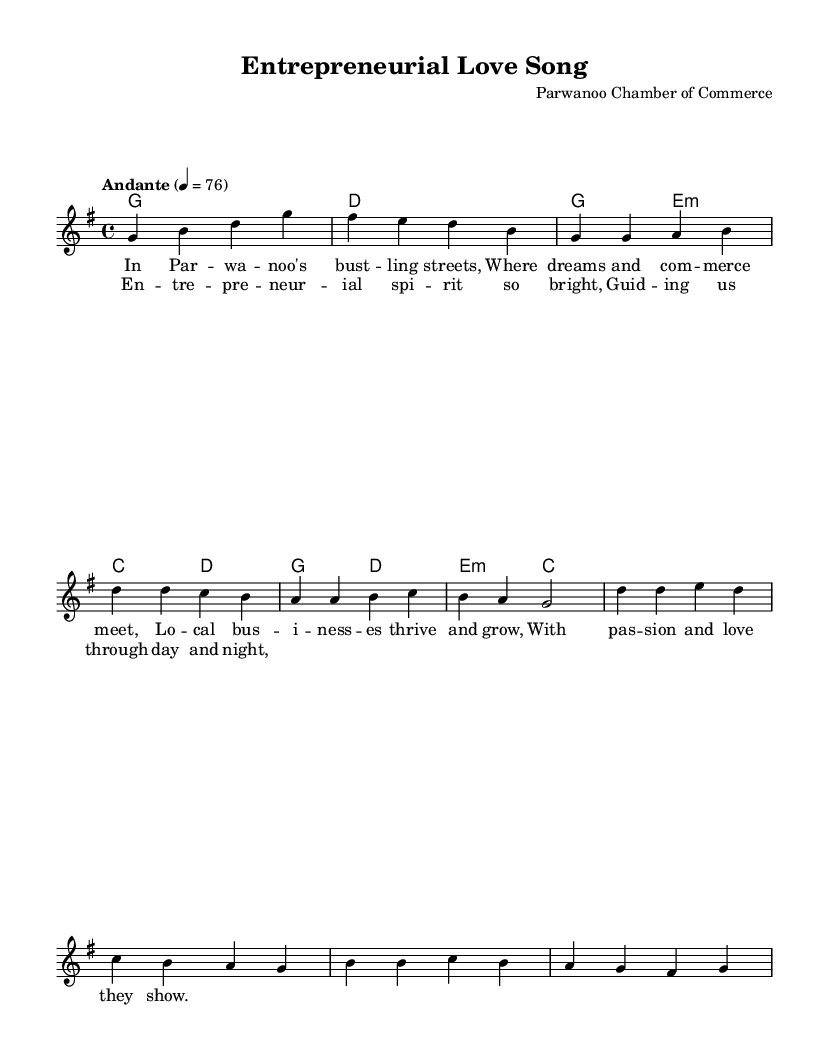What is the key signature of this music? The key signature is indicated at the beginning of the sheet music. It shows one sharp, which corresponds to G major.
Answer: G major What is the time signature of this piece? The time signature is displayed after the key signature and indicates the beat structure of the music. It is shown as 4/4, meaning there are four beats in a measure and the quarter note gets one beat.
Answer: 4/4 What is the tempo marking for this composition? The tempo is indicated in the score stating "Andante" and a metronome marking of 76 beats per minute, which signifies a moderately slow tempo.
Answer: Andante, 76 How many measures are there in the verse section? The verse section consists of a series of musical phrases, and by counting the individual measures notated, it can be determined that there are four measures in the verse.
Answer: 4 Which chord is played during the chorus? The chords during the chorus can be found in the harmonies section and specifically, the chorus starts with the G major chord and transitions to the D major chord.
Answer: G, D What lyrical theme is introduced in the first verse? The first verse describes the local business environment and the thriving nature of entrepreneurship in Parwanoo, emphasizing passion and community support.
Answer: Local businesses thrive Which phrase starts the chorus? The chorus begins with the phrase "Entrepreneurial spirit so bright," and this sets the motivational tone for the section, focusing on the essence of entrepreneurship.
Answer: Entrepreneurial spirit so bright 